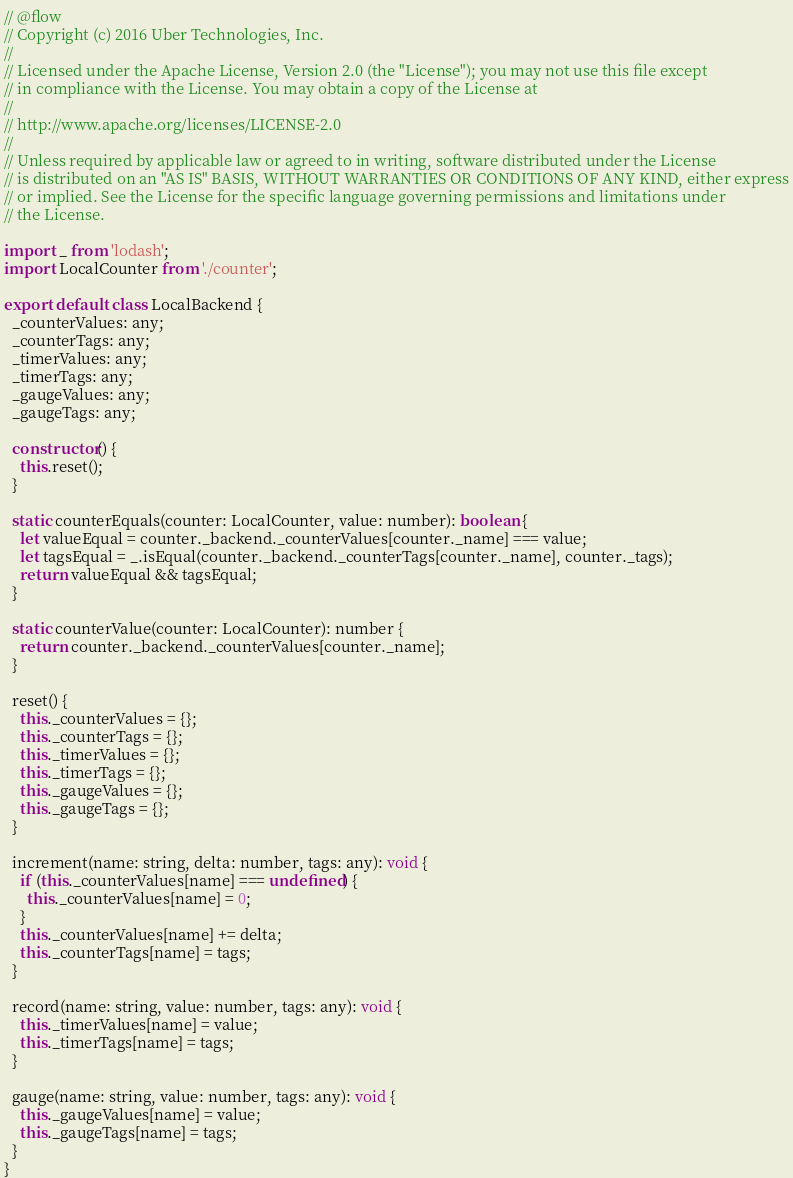<code> <loc_0><loc_0><loc_500><loc_500><_JavaScript_>// @flow
// Copyright (c) 2016 Uber Technologies, Inc.
//
// Licensed under the Apache License, Version 2.0 (the "License"); you may not use this file except
// in compliance with the License. You may obtain a copy of the License at
//
// http://www.apache.org/licenses/LICENSE-2.0
//
// Unless required by applicable law or agreed to in writing, software distributed under the License
// is distributed on an "AS IS" BASIS, WITHOUT WARRANTIES OR CONDITIONS OF ANY KIND, either express
// or implied. See the License for the specific language governing permissions and limitations under
// the License.

import _ from 'lodash';
import LocalCounter from './counter';

export default class LocalBackend {
  _counterValues: any;
  _counterTags: any;
  _timerValues: any;
  _timerTags: any;
  _gaugeValues: any;
  _gaugeTags: any;

  constructor() {
    this.reset();
  }

  static counterEquals(counter: LocalCounter, value: number): boolean {
    let valueEqual = counter._backend._counterValues[counter._name] === value;
    let tagsEqual = _.isEqual(counter._backend._counterTags[counter._name], counter._tags);
    return valueEqual && tagsEqual;
  }

  static counterValue(counter: LocalCounter): number {
    return counter._backend._counterValues[counter._name];
  }

  reset() {
    this._counterValues = {};
    this._counterTags = {};
    this._timerValues = {};
    this._timerTags = {};
    this._gaugeValues = {};
    this._gaugeTags = {};
  }

  increment(name: string, delta: number, tags: any): void {
    if (this._counterValues[name] === undefined) {
      this._counterValues[name] = 0;
    }
    this._counterValues[name] += delta;
    this._counterTags[name] = tags;
  }

  record(name: string, value: number, tags: any): void {
    this._timerValues[name] = value;
    this._timerTags[name] = tags;
  }

  gauge(name: string, value: number, tags: any): void {
    this._gaugeValues[name] = value;
    this._gaugeTags[name] = tags;
  }
}
</code> 